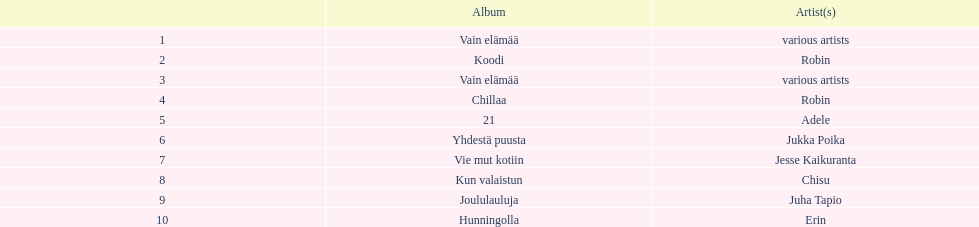Who has sold more records, adele or chisu? Adele. 